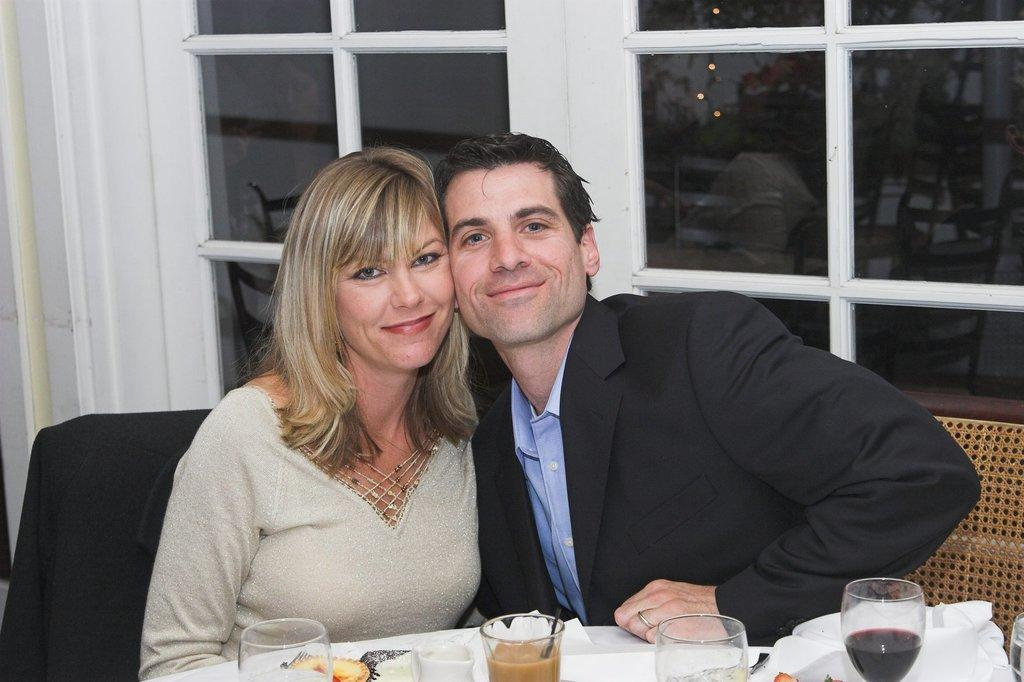How many people are sitting in the image? There are two people sitting on chairs in the image. What can be seen in the background of the image? There is a glass window in the background. What is present on the table in the image? There is a table in the image with a glass object, food, and papers on it. What is the reaction of the food to the presence of the tongue in the image? There is no tongue present in the image, so there is no reaction to be observed. 